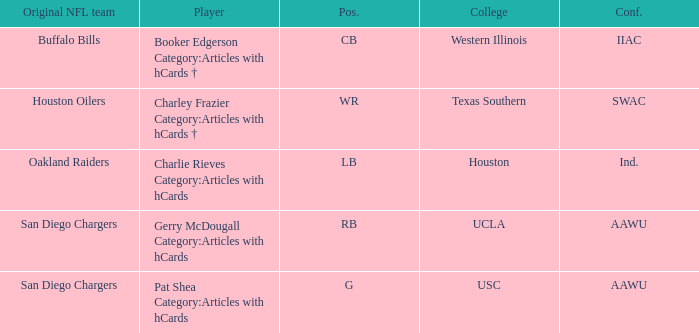What player's original team are the Oakland Raiders? Charlie Rieves Category:Articles with hCards. 